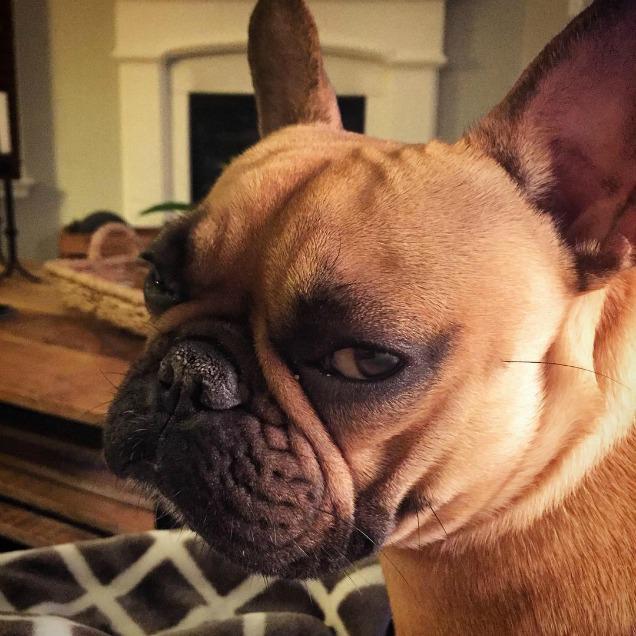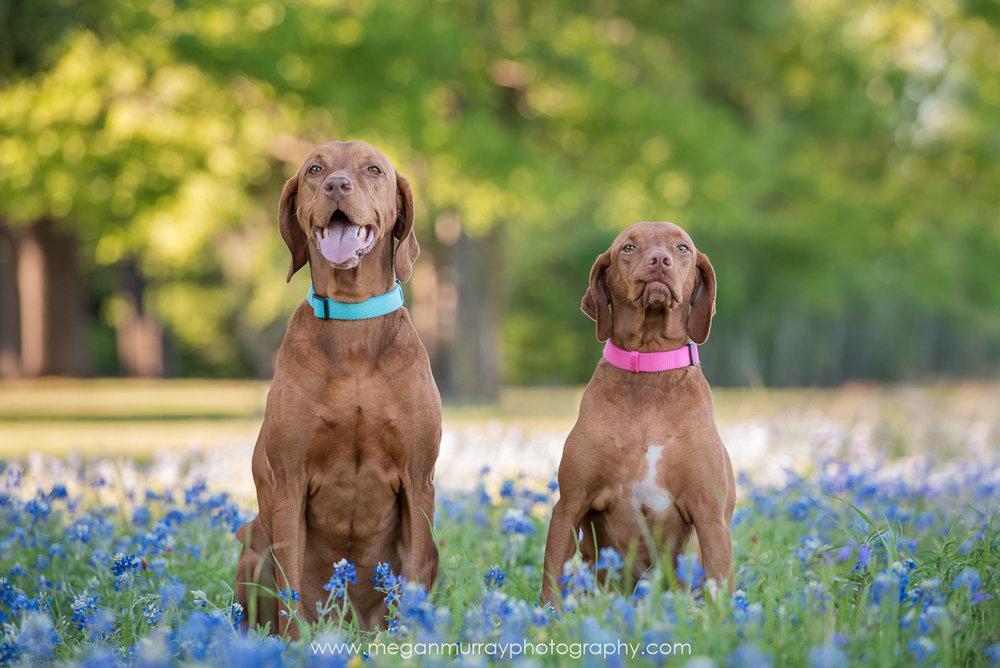The first image is the image on the left, the second image is the image on the right. Given the left and right images, does the statement "There are three animals." hold true? Answer yes or no. Yes. 